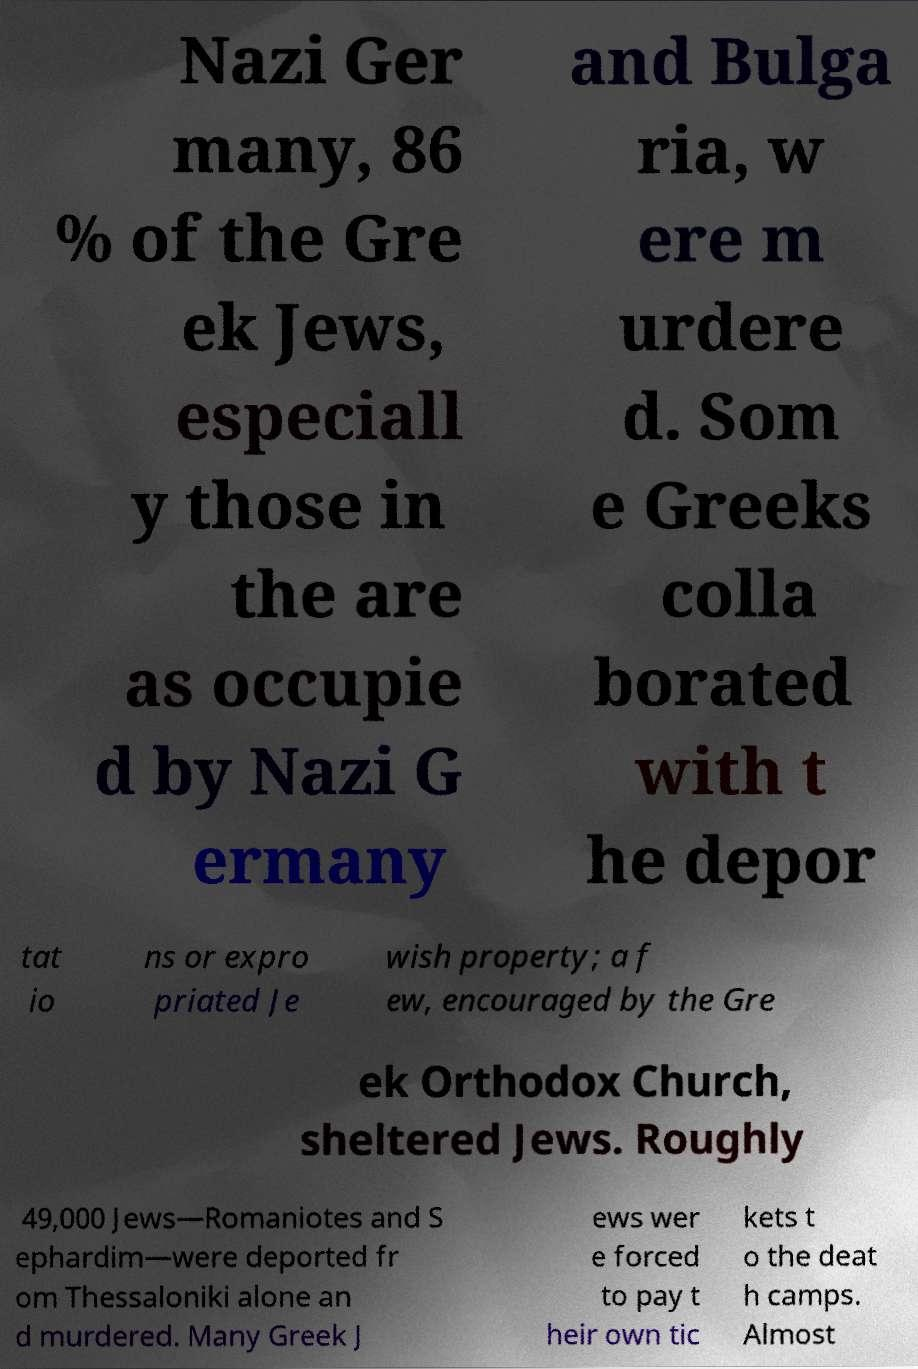I need the written content from this picture converted into text. Can you do that? Nazi Ger many, 86 % of the Gre ek Jews, especiall y those in the are as occupie d by Nazi G ermany and Bulga ria, w ere m urdere d. Som e Greeks colla borated with t he depor tat io ns or expro priated Je wish property; a f ew, encouraged by the Gre ek Orthodox Church, sheltered Jews. Roughly 49,000 Jews—Romaniotes and S ephardim—were deported fr om Thessaloniki alone an d murdered. Many Greek J ews wer e forced to pay t heir own tic kets t o the deat h camps. Almost 